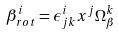<formula> <loc_0><loc_0><loc_500><loc_500>\beta ^ { i } _ { r o t } = \epsilon ^ { i } _ { j k } x ^ { j } \Omega _ { \beta } ^ { k }</formula> 